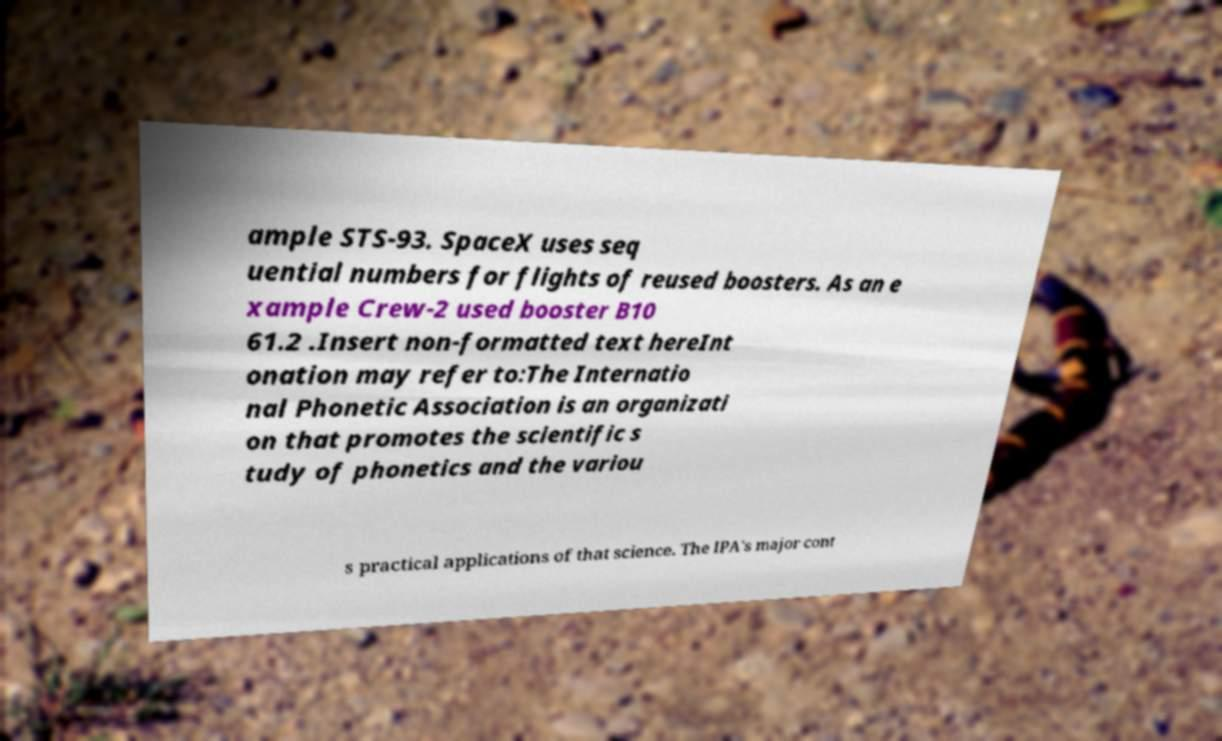I need the written content from this picture converted into text. Can you do that? ample STS-93. SpaceX uses seq uential numbers for flights of reused boosters. As an e xample Crew-2 used booster B10 61.2 .Insert non-formatted text hereInt onation may refer to:The Internatio nal Phonetic Association is an organizati on that promotes the scientific s tudy of phonetics and the variou s practical applications of that science. The IPA's major cont 